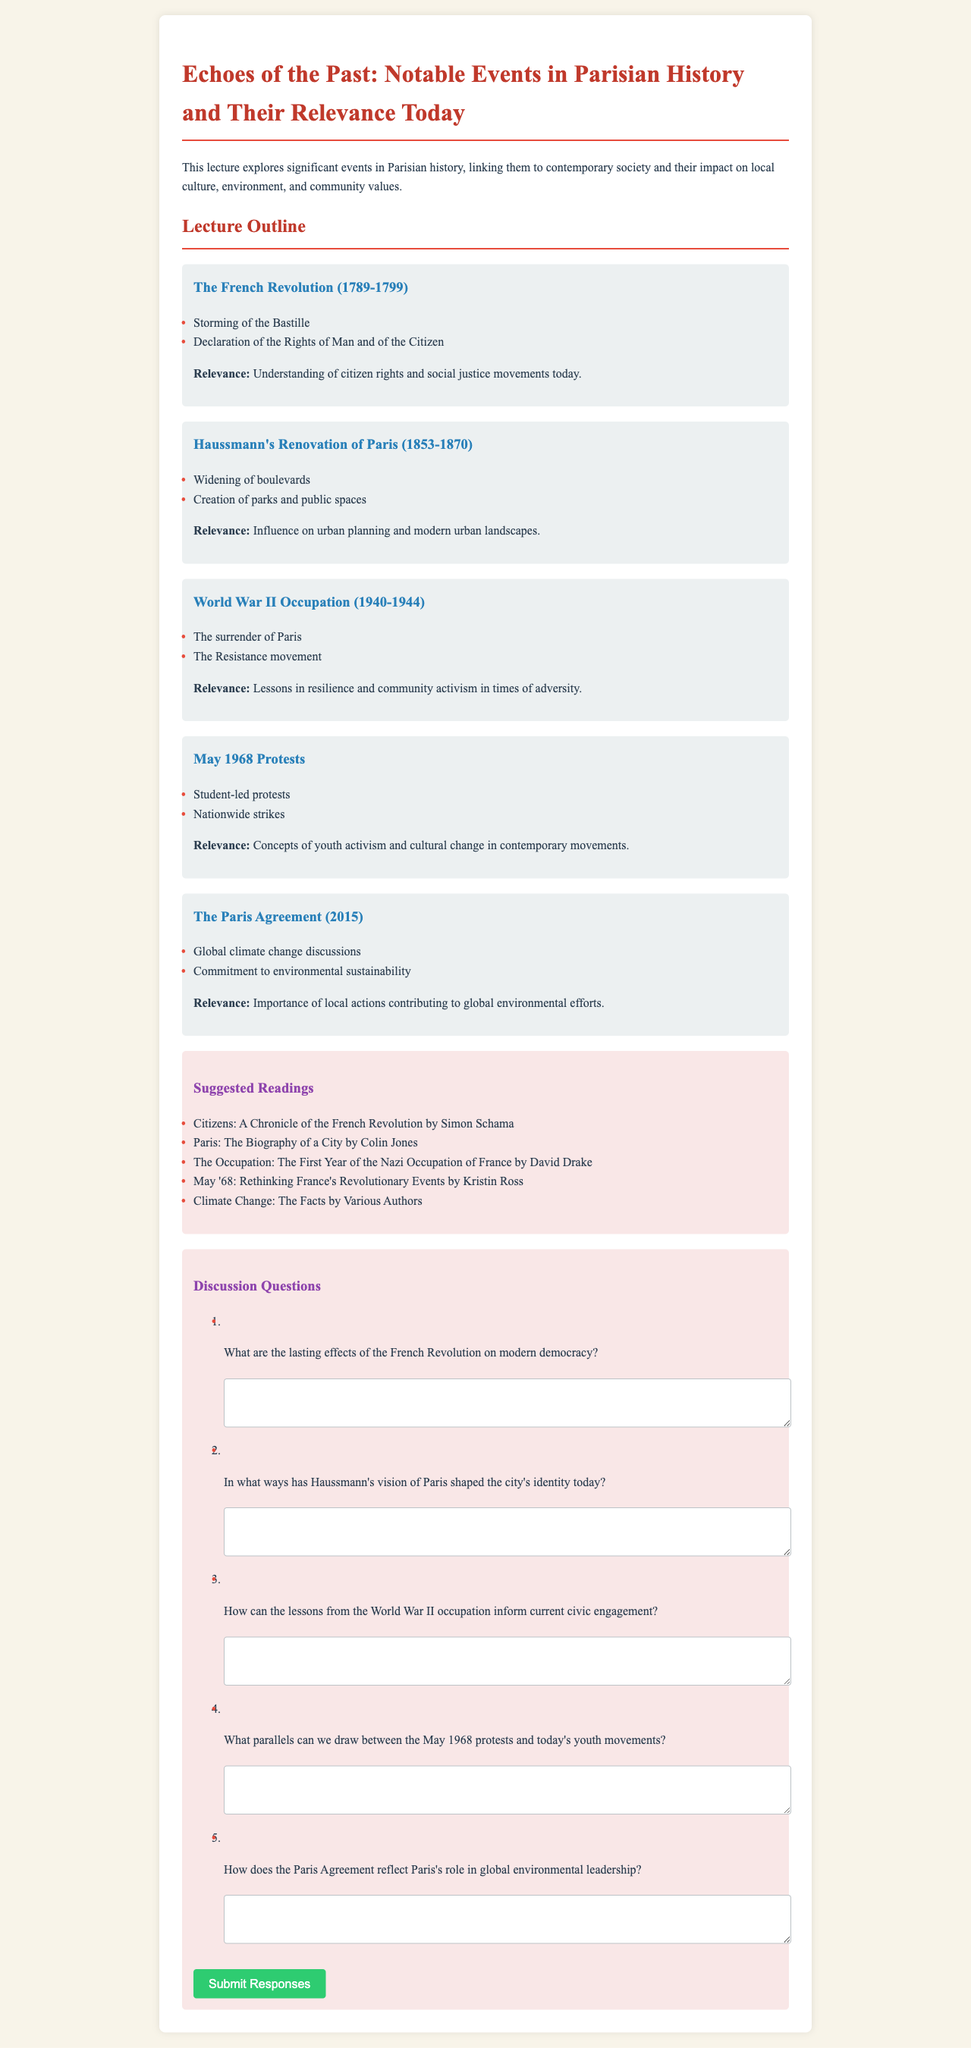What is the title of the lecture? The title is stated at the beginning of the document.
Answer: Echoes of the Past: Notable Events in Parisian History and Their Relevance Today Which year marks the beginning of the French Revolution? The document specifies the duration of the French Revolution as from 1789 to 1799.
Answer: 1789 What significant event is associated with Haussmann's Renovation of Paris? The document lists key aspects of Haussmann's renovation, including the widening of boulevards.
Answer: Widening of boulevards What is one lesson from the World War II occupation mentioned in the document? The document highlights the importance of lessons learned in resilience and community activism.
Answer: Resilience Which reading is suggested for understanding the French Revolution? The document lists several suggested readings, including one specifically about the French Revolution.
Answer: Citizens: A Chronicle of the French Revolution by Simon Schama What event did the May 1968 protests focus on? The document features student-led protests as a significant aspect of the May 1968 movement.
Answer: Student-led protests 